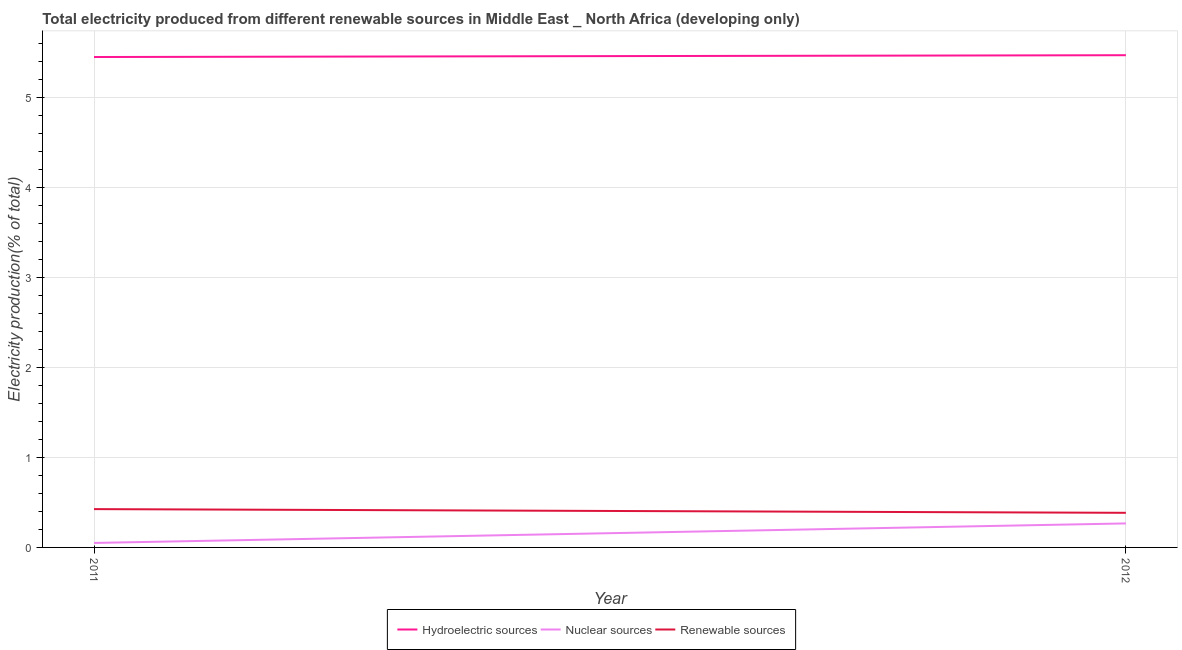How many different coloured lines are there?
Make the answer very short. 3. Is the number of lines equal to the number of legend labels?
Ensure brevity in your answer.  Yes. What is the percentage of electricity produced by hydroelectric sources in 2012?
Your answer should be compact. 5.47. Across all years, what is the maximum percentage of electricity produced by hydroelectric sources?
Offer a very short reply. 5.47. Across all years, what is the minimum percentage of electricity produced by nuclear sources?
Your answer should be compact. 0.05. What is the total percentage of electricity produced by nuclear sources in the graph?
Make the answer very short. 0.32. What is the difference between the percentage of electricity produced by hydroelectric sources in 2011 and that in 2012?
Provide a succinct answer. -0.02. What is the difference between the percentage of electricity produced by hydroelectric sources in 2012 and the percentage of electricity produced by nuclear sources in 2011?
Ensure brevity in your answer.  5.42. What is the average percentage of electricity produced by renewable sources per year?
Make the answer very short. 0.41. In the year 2012, what is the difference between the percentage of electricity produced by hydroelectric sources and percentage of electricity produced by nuclear sources?
Provide a short and direct response. 5.21. In how many years, is the percentage of electricity produced by nuclear sources greater than 4.6 %?
Keep it short and to the point. 0. What is the ratio of the percentage of electricity produced by nuclear sources in 2011 to that in 2012?
Provide a succinct answer. 0.19. Is the percentage of electricity produced by nuclear sources in 2011 less than that in 2012?
Keep it short and to the point. Yes. Does the percentage of electricity produced by renewable sources monotonically increase over the years?
Offer a very short reply. No. Is the percentage of electricity produced by nuclear sources strictly less than the percentage of electricity produced by hydroelectric sources over the years?
Offer a very short reply. Yes. What is the difference between two consecutive major ticks on the Y-axis?
Your answer should be very brief. 1. Does the graph contain grids?
Your answer should be very brief. Yes. How are the legend labels stacked?
Make the answer very short. Horizontal. What is the title of the graph?
Give a very brief answer. Total electricity produced from different renewable sources in Middle East _ North Africa (developing only). What is the label or title of the X-axis?
Make the answer very short. Year. What is the label or title of the Y-axis?
Keep it short and to the point. Electricity production(% of total). What is the Electricity production(% of total) of Hydroelectric sources in 2011?
Your response must be concise. 5.45. What is the Electricity production(% of total) in Nuclear sources in 2011?
Your answer should be compact. 0.05. What is the Electricity production(% of total) in Renewable sources in 2011?
Provide a succinct answer. 0.43. What is the Electricity production(% of total) in Hydroelectric sources in 2012?
Keep it short and to the point. 5.47. What is the Electricity production(% of total) of Nuclear sources in 2012?
Ensure brevity in your answer.  0.27. What is the Electricity production(% of total) of Renewable sources in 2012?
Provide a succinct answer. 0.38. Across all years, what is the maximum Electricity production(% of total) in Hydroelectric sources?
Your response must be concise. 5.47. Across all years, what is the maximum Electricity production(% of total) in Nuclear sources?
Keep it short and to the point. 0.27. Across all years, what is the maximum Electricity production(% of total) in Renewable sources?
Provide a short and direct response. 0.43. Across all years, what is the minimum Electricity production(% of total) of Hydroelectric sources?
Provide a short and direct response. 5.45. Across all years, what is the minimum Electricity production(% of total) of Nuclear sources?
Offer a terse response. 0.05. Across all years, what is the minimum Electricity production(% of total) of Renewable sources?
Keep it short and to the point. 0.38. What is the total Electricity production(% of total) in Hydroelectric sources in the graph?
Give a very brief answer. 10.93. What is the total Electricity production(% of total) of Nuclear sources in the graph?
Provide a short and direct response. 0.32. What is the total Electricity production(% of total) of Renewable sources in the graph?
Your answer should be compact. 0.81. What is the difference between the Electricity production(% of total) in Hydroelectric sources in 2011 and that in 2012?
Provide a short and direct response. -0.02. What is the difference between the Electricity production(% of total) in Nuclear sources in 2011 and that in 2012?
Provide a short and direct response. -0.22. What is the difference between the Electricity production(% of total) in Renewable sources in 2011 and that in 2012?
Your answer should be compact. 0.04. What is the difference between the Electricity production(% of total) in Hydroelectric sources in 2011 and the Electricity production(% of total) in Nuclear sources in 2012?
Offer a very short reply. 5.19. What is the difference between the Electricity production(% of total) in Hydroelectric sources in 2011 and the Electricity production(% of total) in Renewable sources in 2012?
Your answer should be compact. 5.07. What is the difference between the Electricity production(% of total) of Nuclear sources in 2011 and the Electricity production(% of total) of Renewable sources in 2012?
Keep it short and to the point. -0.34. What is the average Electricity production(% of total) of Hydroelectric sources per year?
Your response must be concise. 5.46. What is the average Electricity production(% of total) of Nuclear sources per year?
Give a very brief answer. 0.16. What is the average Electricity production(% of total) of Renewable sources per year?
Your answer should be compact. 0.41. In the year 2011, what is the difference between the Electricity production(% of total) of Hydroelectric sources and Electricity production(% of total) of Nuclear sources?
Provide a short and direct response. 5.4. In the year 2011, what is the difference between the Electricity production(% of total) in Hydroelectric sources and Electricity production(% of total) in Renewable sources?
Keep it short and to the point. 5.03. In the year 2011, what is the difference between the Electricity production(% of total) of Nuclear sources and Electricity production(% of total) of Renewable sources?
Your answer should be very brief. -0.38. In the year 2012, what is the difference between the Electricity production(% of total) of Hydroelectric sources and Electricity production(% of total) of Nuclear sources?
Ensure brevity in your answer.  5.21. In the year 2012, what is the difference between the Electricity production(% of total) in Hydroelectric sources and Electricity production(% of total) in Renewable sources?
Offer a terse response. 5.09. In the year 2012, what is the difference between the Electricity production(% of total) of Nuclear sources and Electricity production(% of total) of Renewable sources?
Offer a terse response. -0.12. What is the ratio of the Electricity production(% of total) of Hydroelectric sources in 2011 to that in 2012?
Offer a very short reply. 1. What is the ratio of the Electricity production(% of total) in Nuclear sources in 2011 to that in 2012?
Provide a succinct answer. 0.19. What is the ratio of the Electricity production(% of total) of Renewable sources in 2011 to that in 2012?
Provide a short and direct response. 1.11. What is the difference between the highest and the second highest Electricity production(% of total) of Hydroelectric sources?
Your answer should be compact. 0.02. What is the difference between the highest and the second highest Electricity production(% of total) in Nuclear sources?
Keep it short and to the point. 0.22. What is the difference between the highest and the second highest Electricity production(% of total) in Renewable sources?
Your answer should be very brief. 0.04. What is the difference between the highest and the lowest Electricity production(% of total) in Hydroelectric sources?
Keep it short and to the point. 0.02. What is the difference between the highest and the lowest Electricity production(% of total) in Nuclear sources?
Your answer should be very brief. 0.22. What is the difference between the highest and the lowest Electricity production(% of total) of Renewable sources?
Give a very brief answer. 0.04. 